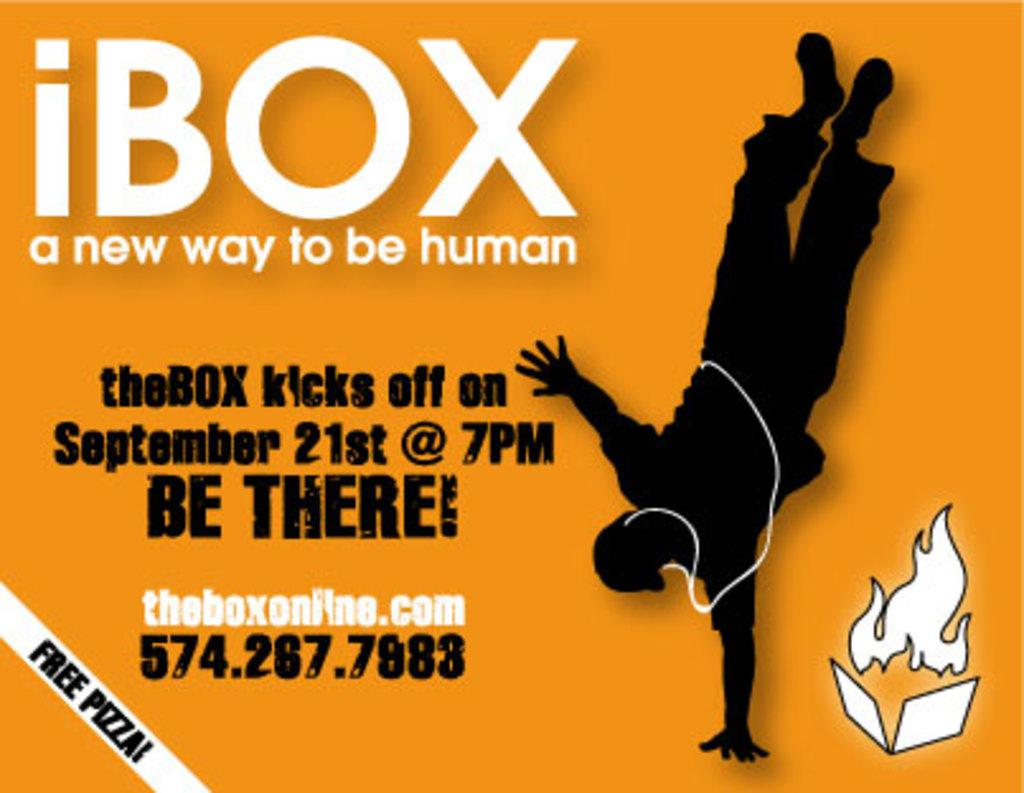What type of image is being described? The image is an edited poster. What information can be found on the poster? There is an organization name on the poster. What is the purpose of the poster? The poster is for promotional purposes. Who is the owner of the question mentioned in the poster? There is no mention of a question or an owner in the image or the provided facts. 